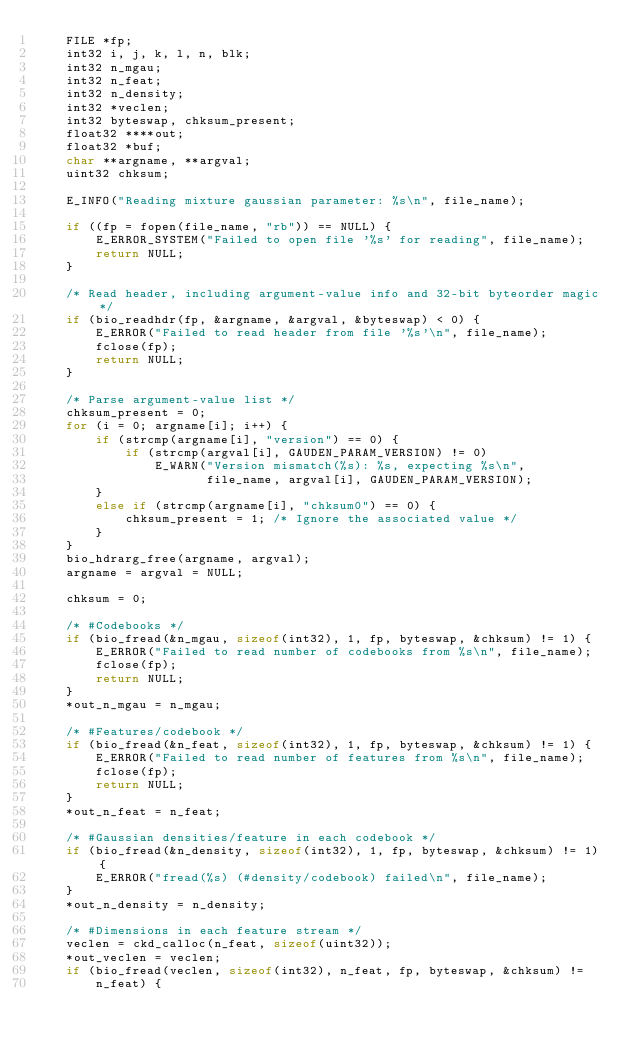<code> <loc_0><loc_0><loc_500><loc_500><_C_>    FILE *fp;
    int32 i, j, k, l, n, blk;
    int32 n_mgau;
    int32 n_feat;
    int32 n_density;
    int32 *veclen;
    int32 byteswap, chksum_present;
    float32 ****out;
    float32 *buf;
    char **argname, **argval;
    uint32 chksum;

    E_INFO("Reading mixture gaussian parameter: %s\n", file_name);

    if ((fp = fopen(file_name, "rb")) == NULL) {
        E_ERROR_SYSTEM("Failed to open file '%s' for reading", file_name);
        return NULL;
    }

    /* Read header, including argument-value info and 32-bit byteorder magic */
    if (bio_readhdr(fp, &argname, &argval, &byteswap) < 0) {
        E_ERROR("Failed to read header from file '%s'\n", file_name);
        fclose(fp);
        return NULL;
    }

    /* Parse argument-value list */
    chksum_present = 0;
    for (i = 0; argname[i]; i++) {
        if (strcmp(argname[i], "version") == 0) {
            if (strcmp(argval[i], GAUDEN_PARAM_VERSION) != 0)
                E_WARN("Version mismatch(%s): %s, expecting %s\n",
                       file_name, argval[i], GAUDEN_PARAM_VERSION);
        }
        else if (strcmp(argname[i], "chksum0") == 0) {
            chksum_present = 1; /* Ignore the associated value */
        }
    }
    bio_hdrarg_free(argname, argval);
    argname = argval = NULL;

    chksum = 0;

    /* #Codebooks */
    if (bio_fread(&n_mgau, sizeof(int32), 1, fp, byteswap, &chksum) != 1) {
        E_ERROR("Failed to read number of codebooks from %s\n", file_name);
        fclose(fp);
        return NULL;
    }
    *out_n_mgau = n_mgau;

    /* #Features/codebook */
    if (bio_fread(&n_feat, sizeof(int32), 1, fp, byteswap, &chksum) != 1) {
        E_ERROR("Failed to read number of features from %s\n", file_name);
        fclose(fp);
        return NULL;
    }
    *out_n_feat = n_feat;

    /* #Gaussian densities/feature in each codebook */
    if (bio_fread(&n_density, sizeof(int32), 1, fp, byteswap, &chksum) != 1) {
        E_ERROR("fread(%s) (#density/codebook) failed\n", file_name);
    }
    *out_n_density = n_density;

    /* #Dimensions in each feature stream */
    veclen = ckd_calloc(n_feat, sizeof(uint32));
    *out_veclen = veclen;
    if (bio_fread(veclen, sizeof(int32), n_feat, fp, byteswap, &chksum) !=
        n_feat) {</code> 